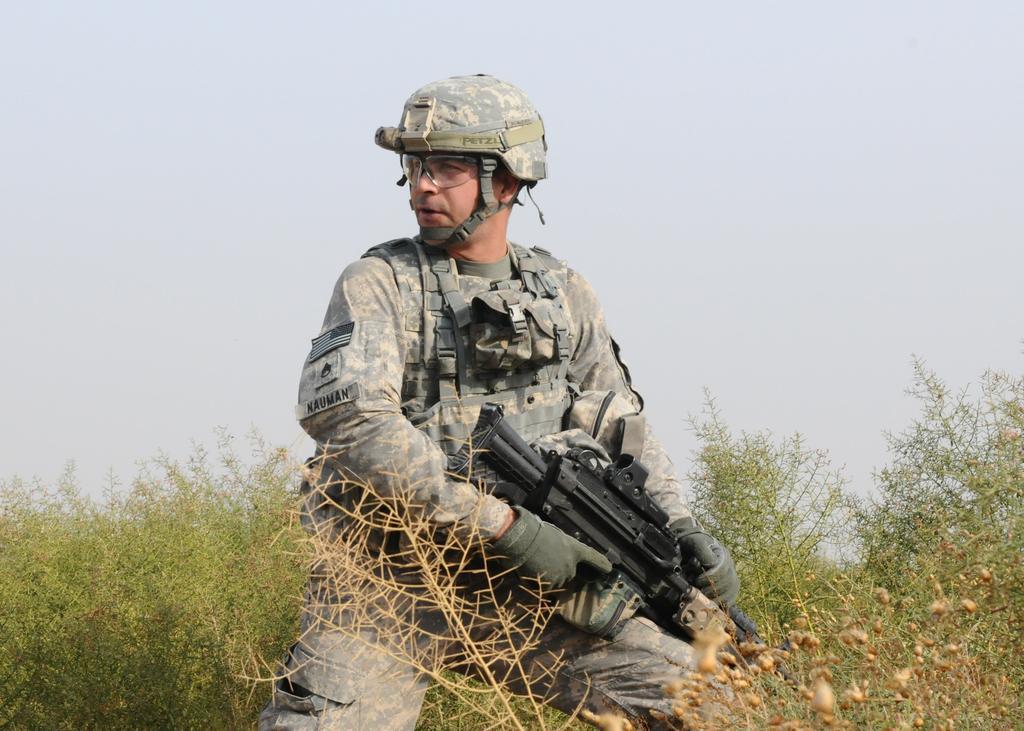How would you summarize this image in a sentence or two? In this picture we can see a man in the army dress and the man is holding a gun. Behind the man there are trees and the sky. 